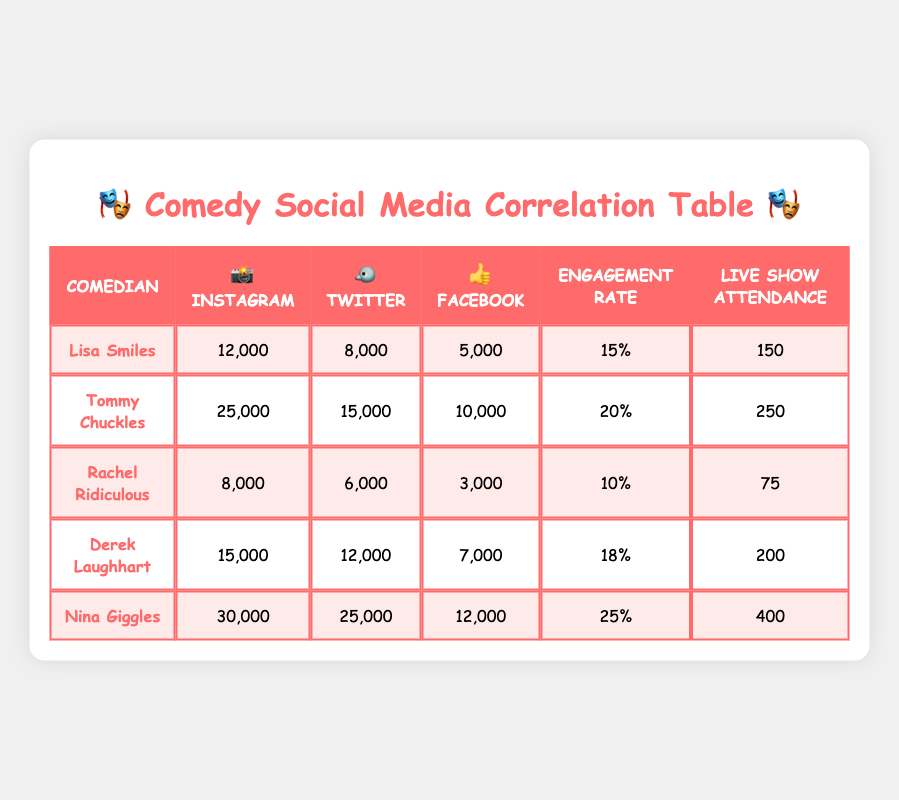What is the live show attendance for Nina Giggles? Nina Giggles is listed in the table with the live show attendance value in the last column. According to the data, her attendance is 400.
Answer: 400 What is Lisa Smiles' average engagement rate? The average engagement rate for Lisa Smiles can be found in her row under the engagement rate column. It shows 15%.
Answer: 15% Which comedian has the highest number of Instagram followers? By inspecting the 'Instagram' column values, it is clear that Nina Giggles has the highest number with 30,000 followers, compared to others in the list.
Answer: Nina Giggles What is the total number of Twitter followers for all comedians combined? Adding up the Twitter followers for all comedians gives: 8000 + 15000 + 6000 + 12000 + 25000 = 68000, so the total number of Twitter followers is 68000.
Answer: 68000 Is it true that Derek Laughhart has more Facebook fans than Tommy Chuckles? Checking the Facebook fans column, Derek Laughhart has 7000 fans, while Tommy Chuckles has 10000. This means it is false that Derek Laughhart has more.
Answer: No What is the average live show attendance for the comedians listed? To find the average, we first sum the attendance numbers: (150 + 250 + 75 + 200 + 400) = 1075. There are 5 comedians, so the average is 1075 / 5 = 215.
Answer: 215 Which comedian has both the highest engagement rate and the highest live show attendance? Analyzing the statistics, Nina Giggles has the highest engagement rate at 25% and also the highest live show attendance at 400. Thus, she meets both criteria.
Answer: Nina Giggles What is the difference in Instagram followers between Tommy Chuckles and Rachel Ridiculous? Tommy Chuckles has 25000 Instagram followers, and Rachel Ridiculous has 8000. Calculating the difference: 25000 - 8000 = 17000.
Answer: 17000 Does Tommy Chuckles have more Facebook fans than Lisa Smiles? Looking at the Facebook fans column shows that Tommy Chuckles has 10000 fans while Lisa Smiles only has 5000. Therefore, it is true that Tommy Chuckles has more fans.
Answer: Yes 